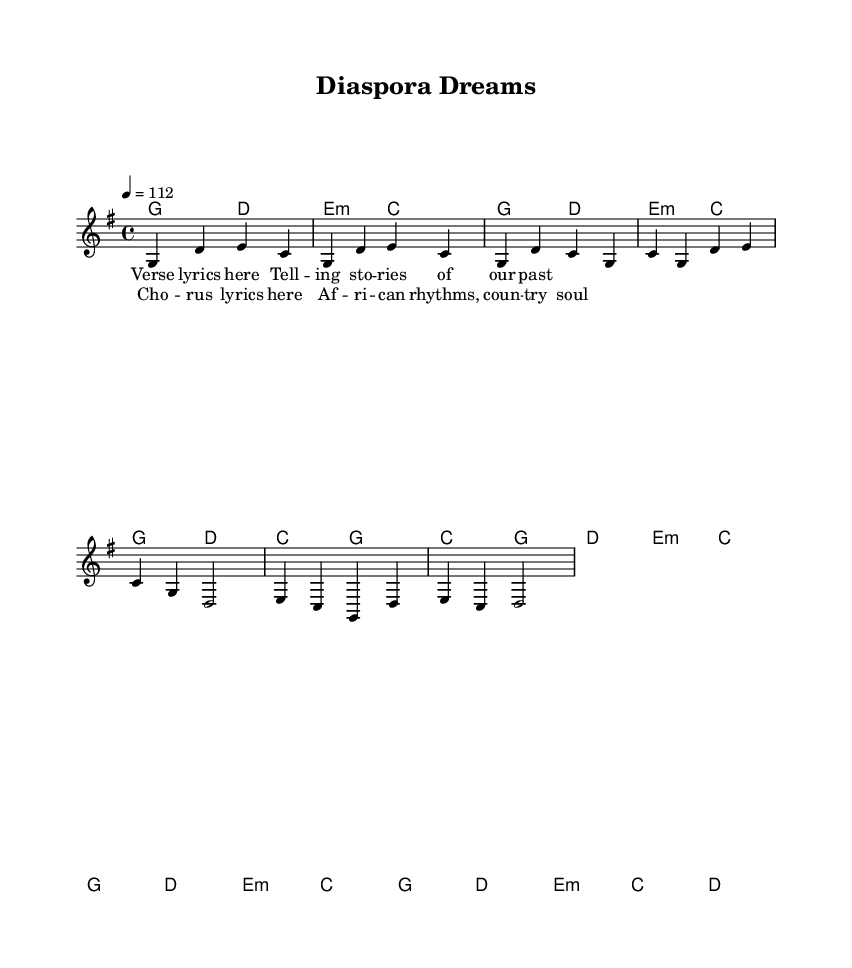What is the key signature of this music? The key signature is G major, which has one sharp (F#). This is indicated at the beginning of the score.
Answer: G major What is the time signature of this music? The time signature shown is 4/4. This means there are four beats in each measure, and a quarter note gets one beat. It is indicated at the start of the score.
Answer: 4/4 What is the tempo marking for this piece? The tempo is marked as 4 equals 112, which sets the speed of the music. This indicates that there are 112 quarter-note beats per minute.
Answer: 112 How many measures are in the chorus section? The chorus contains four measures. By counting the measures in the staff, we see that it spans from the start of the chorus lyrics to the end.
Answer: 4 Which musical style is represented in this piece? The piece is a fusion of Country Rock, as indicated by its genre title and the elements present in the music, specifically the incorporation of African rhythms in the storytelling.
Answer: Country Rock What chord follows the E minor chord in the chorus? In the chorus, after the E minor chord, the C chord appears next. This can be seen in the harmony part where it sequences through the measures.
Answer: C Which rhythm is used to represent African storytelling in this composition? African rhythms in this composition are represented by the syncopated beats and a blend of traditional African rhythmic patterns interwoven into the melody and harmony. While the sheet music doesn't explicitly show these rhythms, they guide the musical expression linked to storytelling.
Answer: Syncopation 